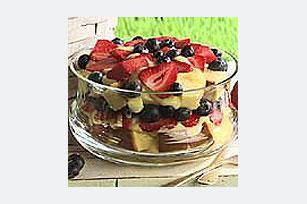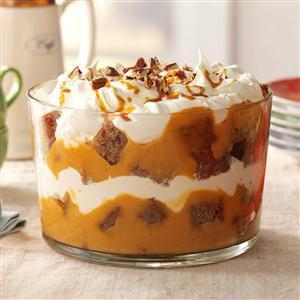The first image is the image on the left, the second image is the image on the right. Given the left and right images, does the statement "There is one large trifle bowl that has fresh strawberries and blueberries on top." hold true? Answer yes or no. Yes. The first image is the image on the left, the second image is the image on the right. Given the left and right images, does the statement "There are two dessert cups sitting in a diagonal line in the image on the right." hold true? Answer yes or no. No. 